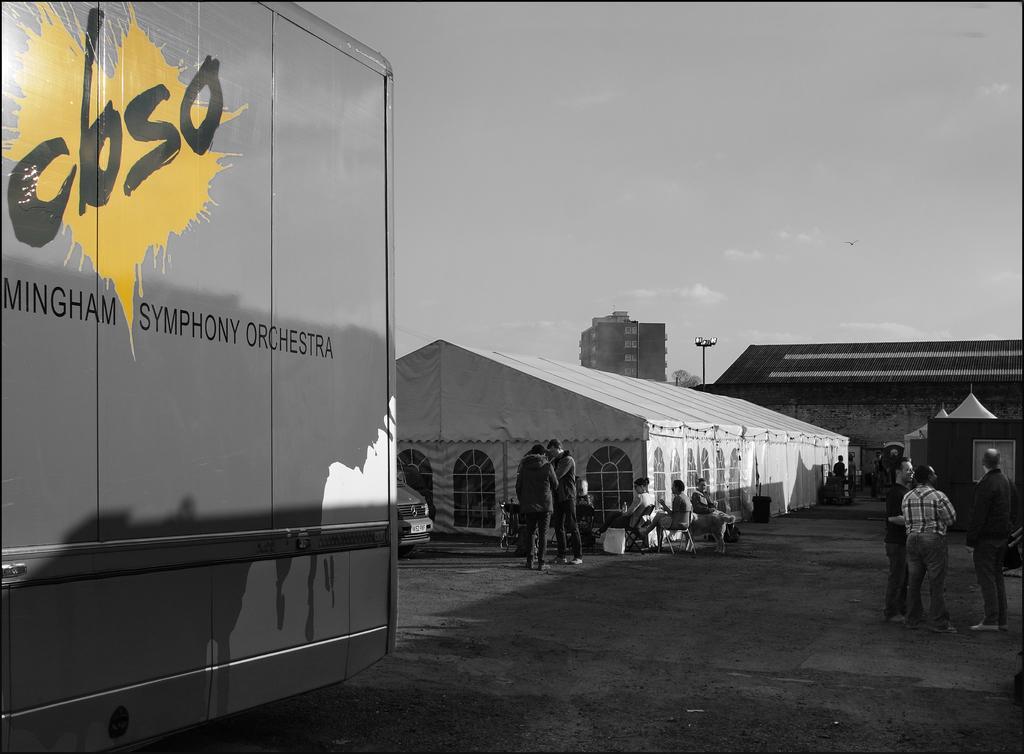How would you summarize this image in a sentence or two? This is a black and white picture of few persons standing and sitting in front of godown, on the left side there is a vehicle, in the back there are buildings and above its sky with clouds. 